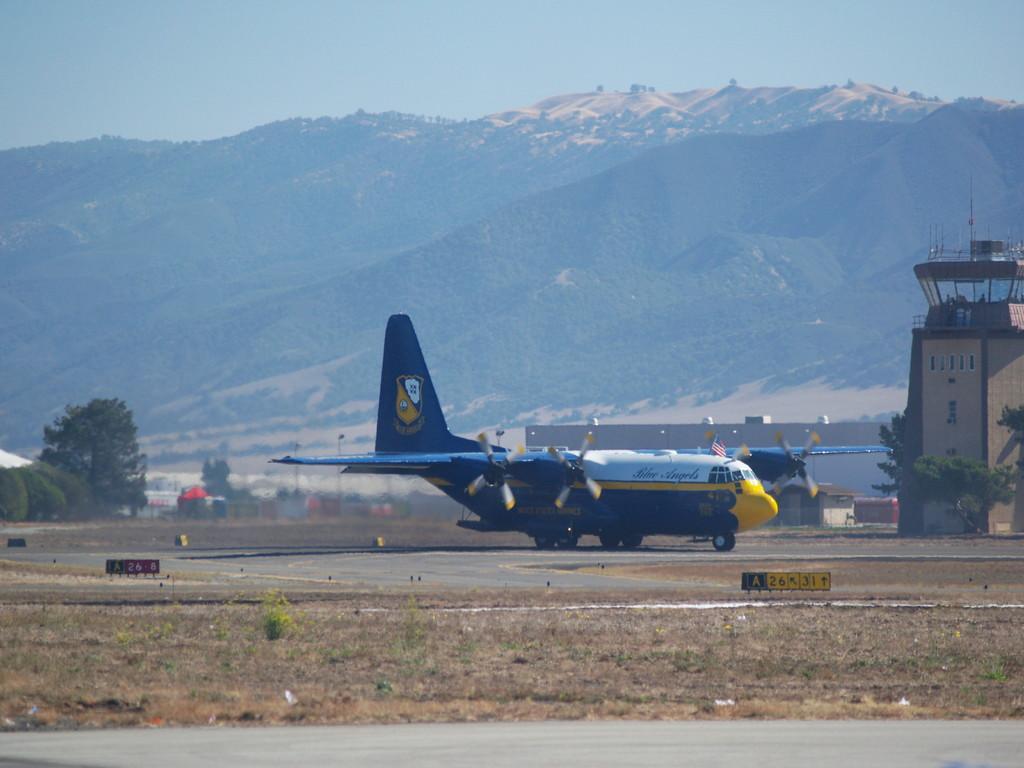Can you describe this image briefly? In this picture I can see the aircraft. I can see trees. I can see the road. I can see the hill. I can see clouds in the sky. 